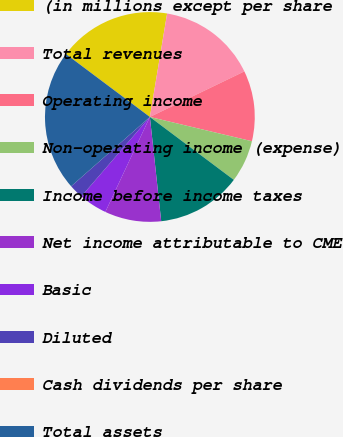Convert chart to OTSL. <chart><loc_0><loc_0><loc_500><loc_500><pie_chart><fcel>(in millions except per share<fcel>Total revenues<fcel>Operating income<fcel>Non-operating income (expense)<fcel>Income before income taxes<fcel>Net income attributable to CME<fcel>Basic<fcel>Diluted<fcel>Cash dividends per share<fcel>Total assets<nl><fcel>17.39%<fcel>15.22%<fcel>10.87%<fcel>6.52%<fcel>13.04%<fcel>8.7%<fcel>4.35%<fcel>2.18%<fcel>0.0%<fcel>21.73%<nl></chart> 